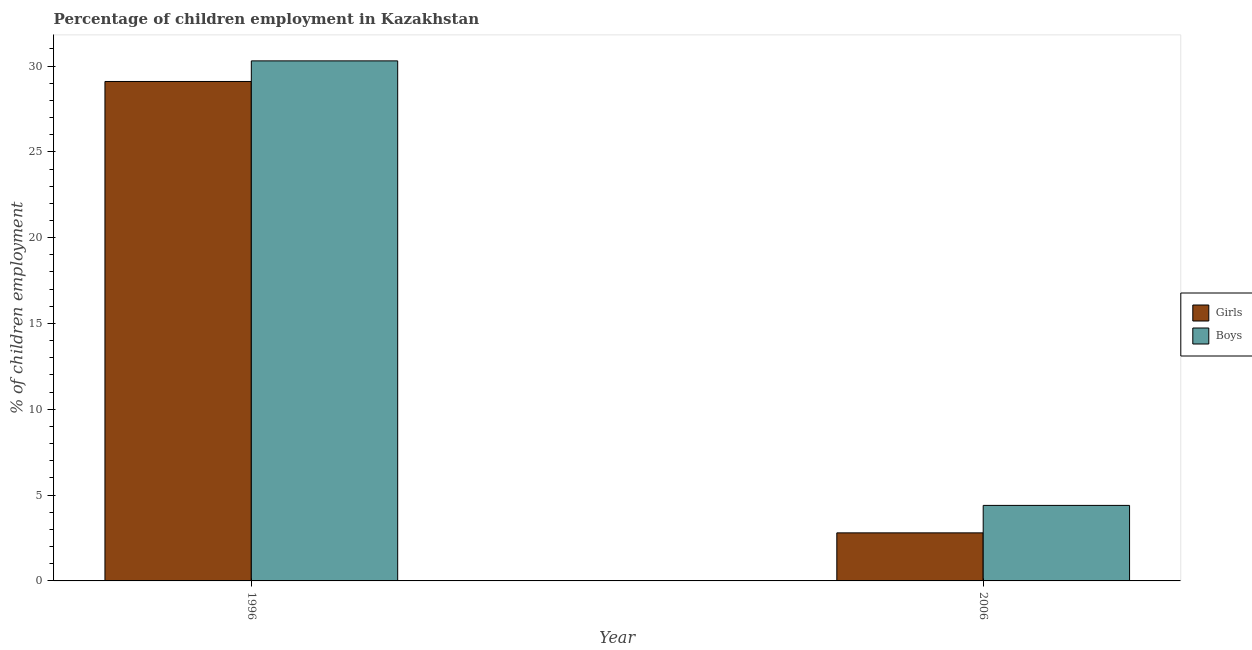How many different coloured bars are there?
Give a very brief answer. 2. Are the number of bars per tick equal to the number of legend labels?
Ensure brevity in your answer.  Yes. What is the label of the 1st group of bars from the left?
Make the answer very short. 1996. Across all years, what is the maximum percentage of employed boys?
Provide a succinct answer. 30.3. What is the total percentage of employed girls in the graph?
Your response must be concise. 31.9. What is the difference between the percentage of employed boys in 1996 and that in 2006?
Keep it short and to the point. 25.9. What is the difference between the percentage of employed boys in 1996 and the percentage of employed girls in 2006?
Provide a short and direct response. 25.9. What is the average percentage of employed girls per year?
Make the answer very short. 15.95. In the year 1996, what is the difference between the percentage of employed girls and percentage of employed boys?
Ensure brevity in your answer.  0. What is the ratio of the percentage of employed girls in 1996 to that in 2006?
Keep it short and to the point. 10.39. Is the percentage of employed girls in 1996 less than that in 2006?
Keep it short and to the point. No. In how many years, is the percentage of employed girls greater than the average percentage of employed girls taken over all years?
Ensure brevity in your answer.  1. What does the 2nd bar from the left in 2006 represents?
Your answer should be very brief. Boys. What does the 1st bar from the right in 2006 represents?
Provide a succinct answer. Boys. How many years are there in the graph?
Your response must be concise. 2. Where does the legend appear in the graph?
Your answer should be very brief. Center right. How many legend labels are there?
Your response must be concise. 2. What is the title of the graph?
Provide a succinct answer. Percentage of children employment in Kazakhstan. Does "Services" appear as one of the legend labels in the graph?
Offer a very short reply. No. What is the label or title of the X-axis?
Give a very brief answer. Year. What is the label or title of the Y-axis?
Offer a terse response. % of children employment. What is the % of children employment of Girls in 1996?
Your answer should be very brief. 29.1. What is the % of children employment in Boys in 1996?
Make the answer very short. 30.3. What is the % of children employment in Girls in 2006?
Offer a terse response. 2.8. What is the % of children employment of Boys in 2006?
Offer a very short reply. 4.4. Across all years, what is the maximum % of children employment of Girls?
Make the answer very short. 29.1. Across all years, what is the maximum % of children employment in Boys?
Offer a terse response. 30.3. Across all years, what is the minimum % of children employment in Boys?
Keep it short and to the point. 4.4. What is the total % of children employment in Girls in the graph?
Provide a short and direct response. 31.9. What is the total % of children employment of Boys in the graph?
Provide a short and direct response. 34.7. What is the difference between the % of children employment of Girls in 1996 and that in 2006?
Offer a very short reply. 26.3. What is the difference between the % of children employment of Boys in 1996 and that in 2006?
Offer a terse response. 25.9. What is the difference between the % of children employment of Girls in 1996 and the % of children employment of Boys in 2006?
Provide a short and direct response. 24.7. What is the average % of children employment of Girls per year?
Give a very brief answer. 15.95. What is the average % of children employment in Boys per year?
Your response must be concise. 17.35. In the year 1996, what is the difference between the % of children employment of Girls and % of children employment of Boys?
Your answer should be compact. -1.2. What is the ratio of the % of children employment of Girls in 1996 to that in 2006?
Your answer should be compact. 10.39. What is the ratio of the % of children employment in Boys in 1996 to that in 2006?
Provide a succinct answer. 6.89. What is the difference between the highest and the second highest % of children employment of Girls?
Your answer should be compact. 26.3. What is the difference between the highest and the second highest % of children employment in Boys?
Keep it short and to the point. 25.9. What is the difference between the highest and the lowest % of children employment of Girls?
Provide a succinct answer. 26.3. What is the difference between the highest and the lowest % of children employment in Boys?
Keep it short and to the point. 25.9. 